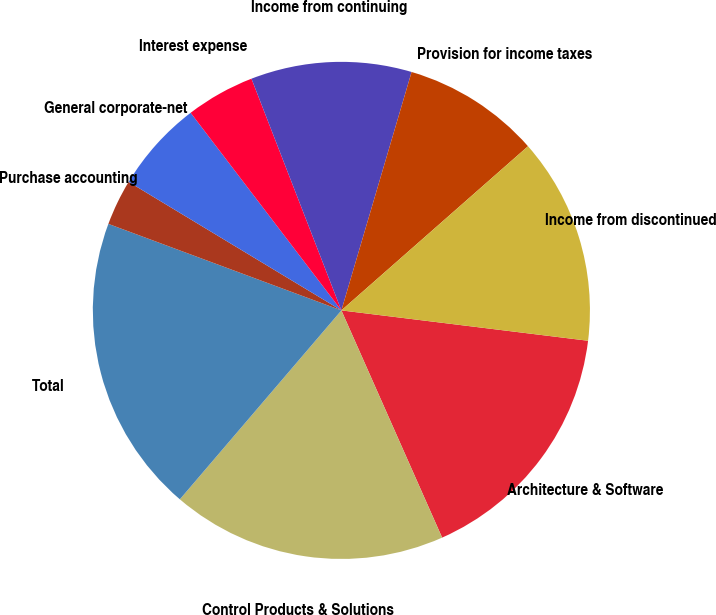<chart> <loc_0><loc_0><loc_500><loc_500><pie_chart><fcel>Architecture & Software<fcel>Control Products & Solutions<fcel>Total<fcel>Purchase accounting<fcel>General corporate-net<fcel>Interest expense<fcel>Income from continuing<fcel>Provision for income taxes<fcel>Income from discontinued<nl><fcel>16.41%<fcel>17.9%<fcel>19.4%<fcel>2.99%<fcel>5.98%<fcel>4.48%<fcel>10.45%<fcel>8.96%<fcel>13.43%<nl></chart> 